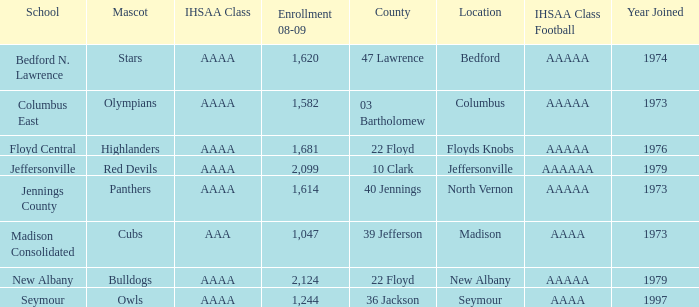What school is in 36 Jackson? Seymour. 